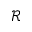<formula> <loc_0><loc_0><loc_500><loc_500>\mathcal { R }</formula> 